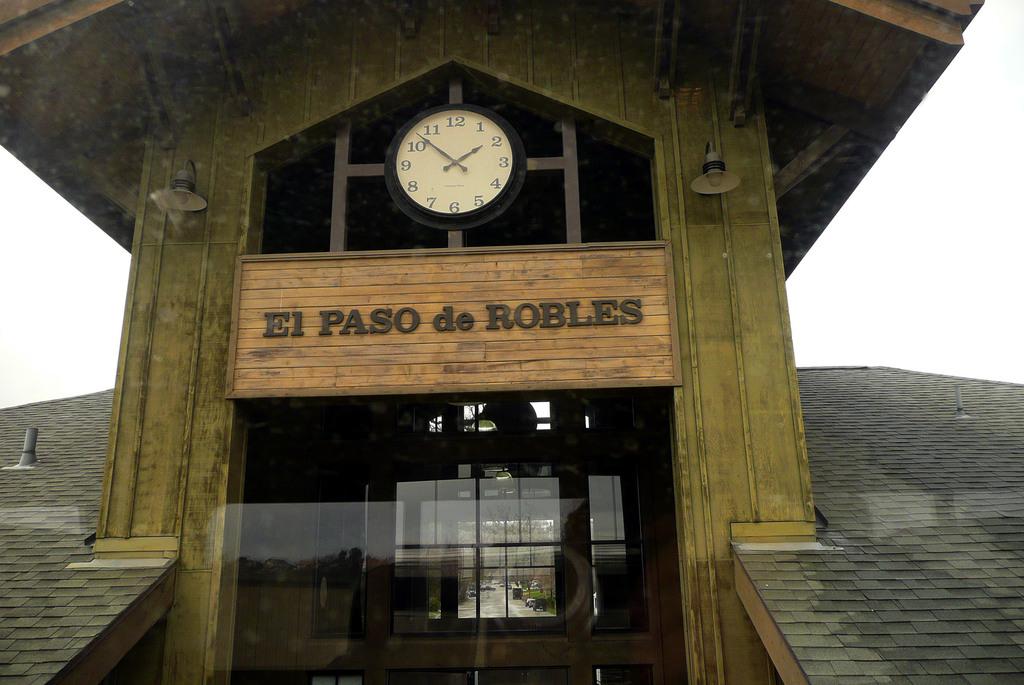What time is it?
Provide a succinct answer. 1:53. 